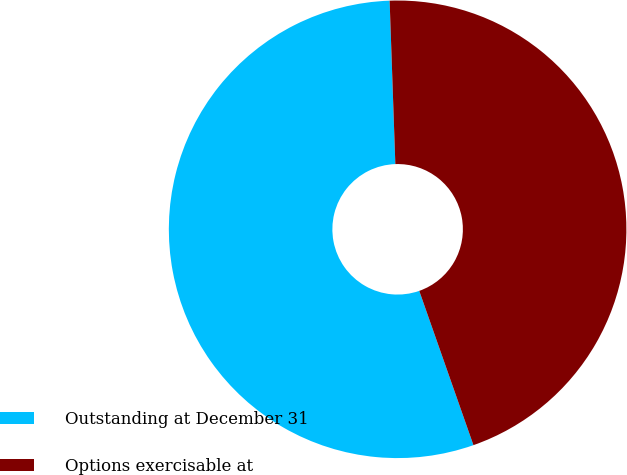<chart> <loc_0><loc_0><loc_500><loc_500><pie_chart><fcel>Outstanding at December 31<fcel>Options exercisable at<nl><fcel>54.82%<fcel>45.18%<nl></chart> 